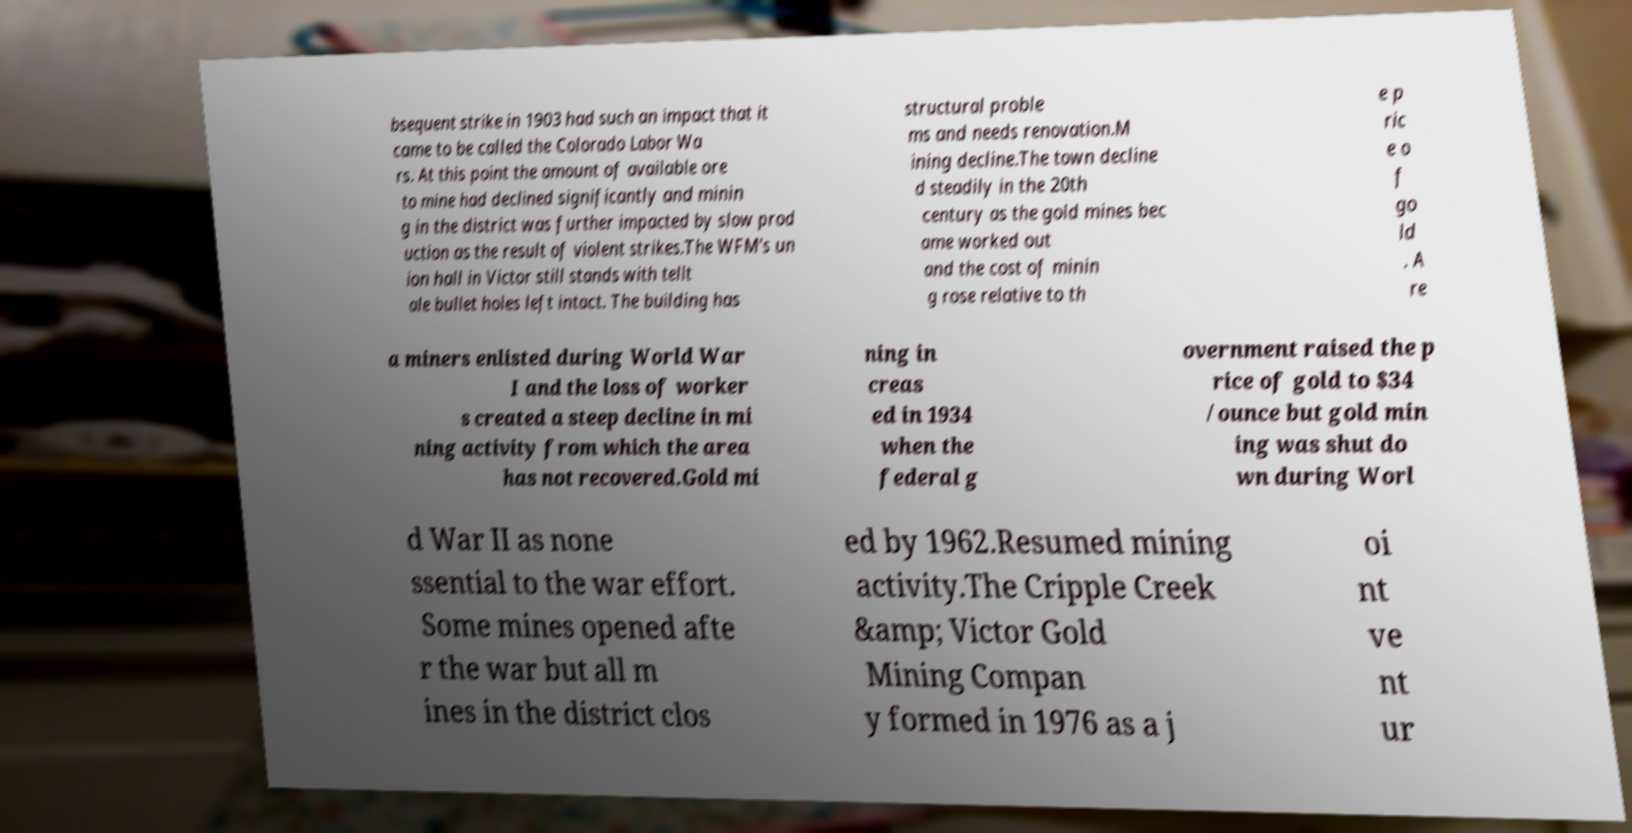What messages or text are displayed in this image? I need them in a readable, typed format. bsequent strike in 1903 had such an impact that it came to be called the Colorado Labor Wa rs. At this point the amount of available ore to mine had declined significantly and minin g in the district was further impacted by slow prod uction as the result of violent strikes.The WFM's un ion hall in Victor still stands with tellt ale bullet holes left intact. The building has structural proble ms and needs renovation.M ining decline.The town decline d steadily in the 20th century as the gold mines bec ame worked out and the cost of minin g rose relative to th e p ric e o f go ld . A re a miners enlisted during World War I and the loss of worker s created a steep decline in mi ning activity from which the area has not recovered.Gold mi ning in creas ed in 1934 when the federal g overnment raised the p rice of gold to $34 /ounce but gold min ing was shut do wn during Worl d War II as none ssential to the war effort. Some mines opened afte r the war but all m ines in the district clos ed by 1962.Resumed mining activity.The Cripple Creek &amp; Victor Gold Mining Compan y formed in 1976 as a j oi nt ve nt ur 